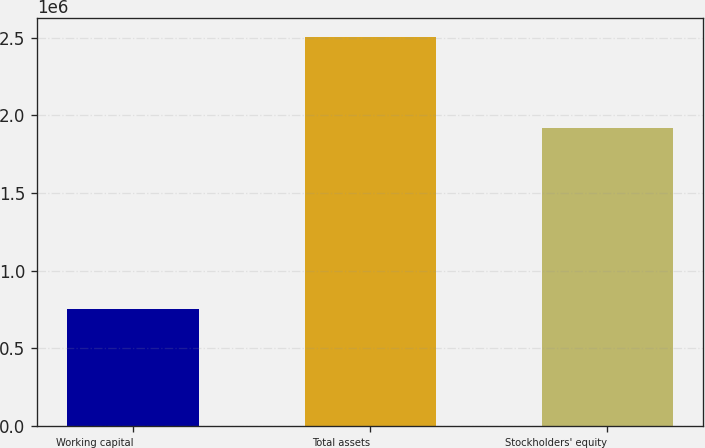<chart> <loc_0><loc_0><loc_500><loc_500><bar_chart><fcel>Working capital<fcel>Total assets<fcel>Stockholders' equity<nl><fcel>751469<fcel>2.5022e+06<fcel>1.91832e+06<nl></chart> 